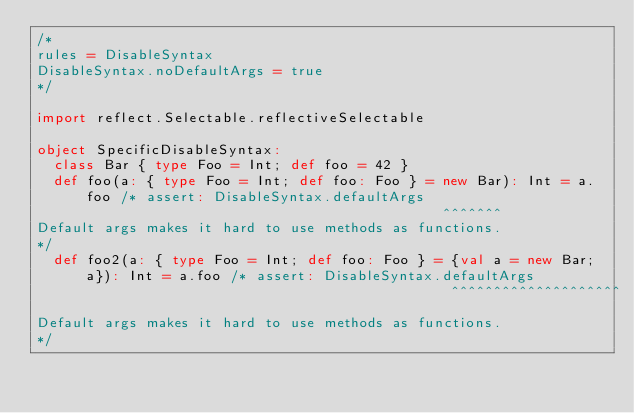Convert code to text. <code><loc_0><loc_0><loc_500><loc_500><_Scala_>/*
rules = DisableSyntax
DisableSyntax.noDefaultArgs = true
*/

import reflect.Selectable.reflectiveSelectable

object SpecificDisableSyntax:
  class Bar { type Foo = Int; def foo = 42 }
  def foo(a: { type Foo = Int; def foo: Foo } = new Bar): Int = a.foo /* assert: DisableSyntax.defaultArgs
                                                ^^^^^^^
Default args makes it hard to use methods as functions.
*/
  def foo2(a: { type Foo = Int; def foo: Foo } = {val a = new Bar; a}): Int = a.foo /* assert: DisableSyntax.defaultArgs
                                                 ^^^^^^^^^^^^^^^^^^^^
Default args makes it hard to use methods as functions.
*/

</code> 